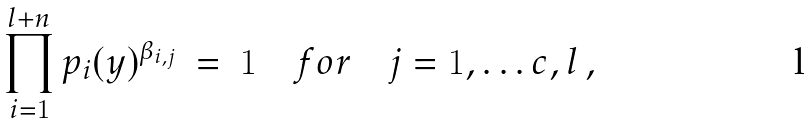<formula> <loc_0><loc_0><loc_500><loc_500>\prod _ { i = 1 } ^ { l + n } p _ { i } ( y ) ^ { \beta _ { i , j } } \ = \ 1 \quad f o r \quad j = 1 , \dots c , l \, ,</formula> 